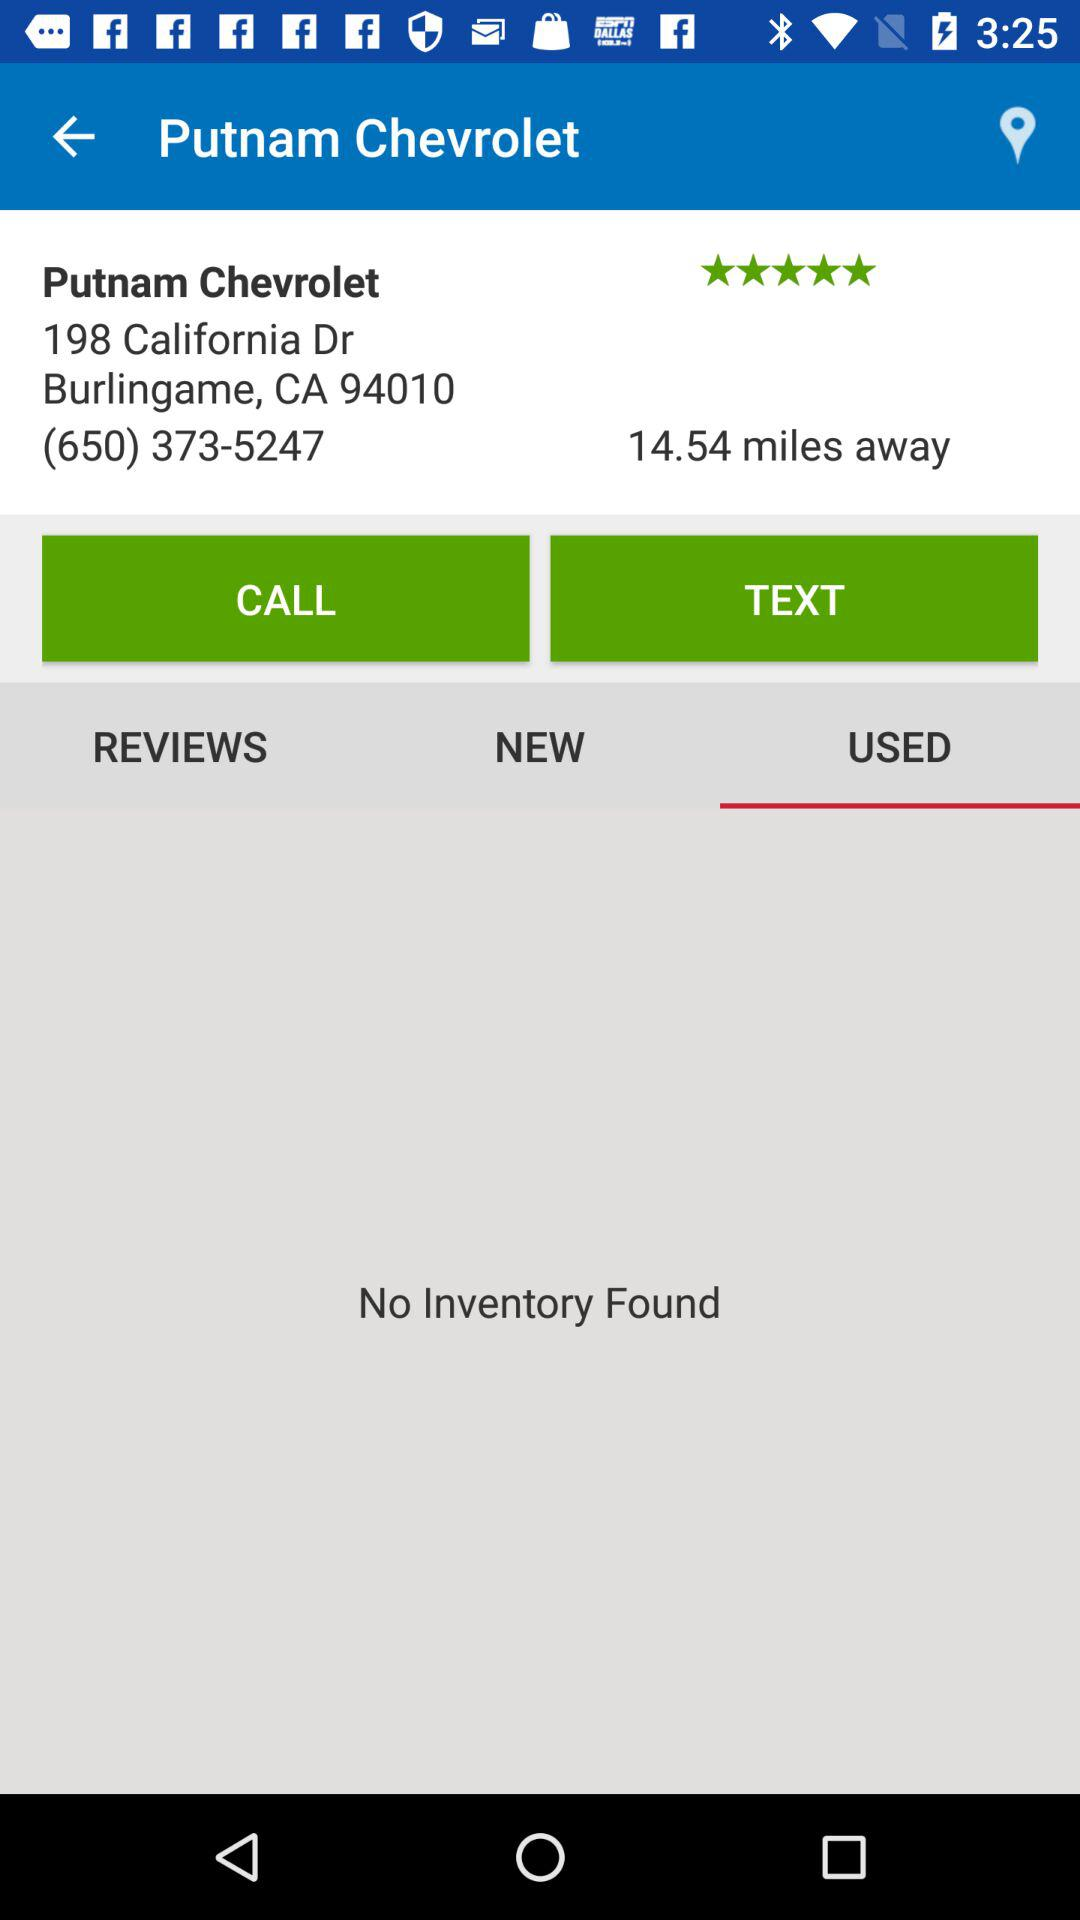What is the given phone number? The given phone number is (650) 373-5247. 